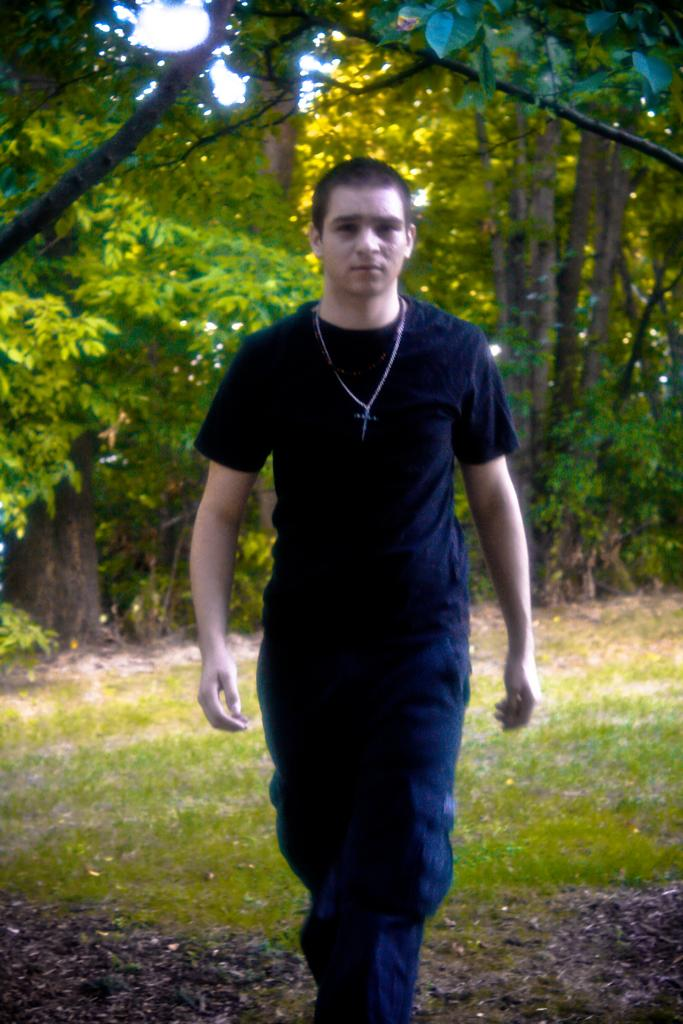Who is present in the image? There is a person in the image. What is the person wearing? The person is wearing a black dress. Where is the person standing? The person is standing on the grass floor. What can be seen in the background of the image? There are trees and plants in the background of the image. What type of toothbrush is the person using in the image? There is no toothbrush present in the image. How does the person transport themselves to the location in the image? The image does not provide information about how the person arrived at the location. 